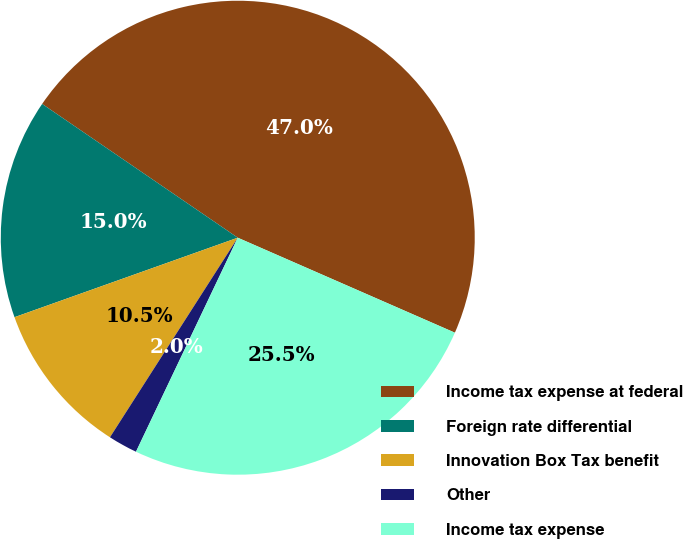<chart> <loc_0><loc_0><loc_500><loc_500><pie_chart><fcel>Income tax expense at federal<fcel>Foreign rate differential<fcel>Innovation Box Tax benefit<fcel>Other<fcel>Income tax expense<nl><fcel>47.01%<fcel>14.99%<fcel>10.49%<fcel>2.0%<fcel>25.5%<nl></chart> 